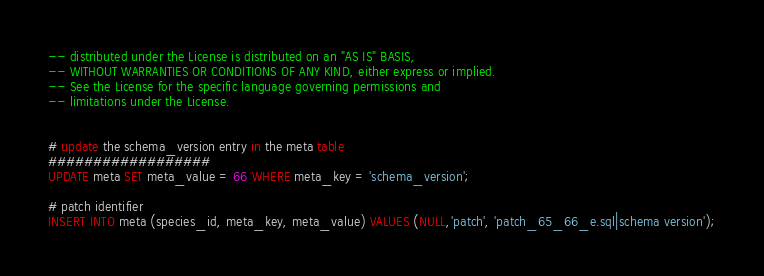<code> <loc_0><loc_0><loc_500><loc_500><_SQL_>-- distributed under the License is distributed on an "AS IS" BASIS,
-- WITHOUT WARRANTIES OR CONDITIONS OF ANY KIND, either express or implied.
-- See the License for the specific language governing permissions and
-- limitations under the License.


# update the schema_version entry in the meta table
##################
UPDATE meta SET meta_value = 66 WHERE meta_key = 'schema_version';

# patch identifier
INSERT INTO meta (species_id, meta_key, meta_value) VALUES (NULL,'patch', 'patch_65_66_e.sql|schema version');
</code> 